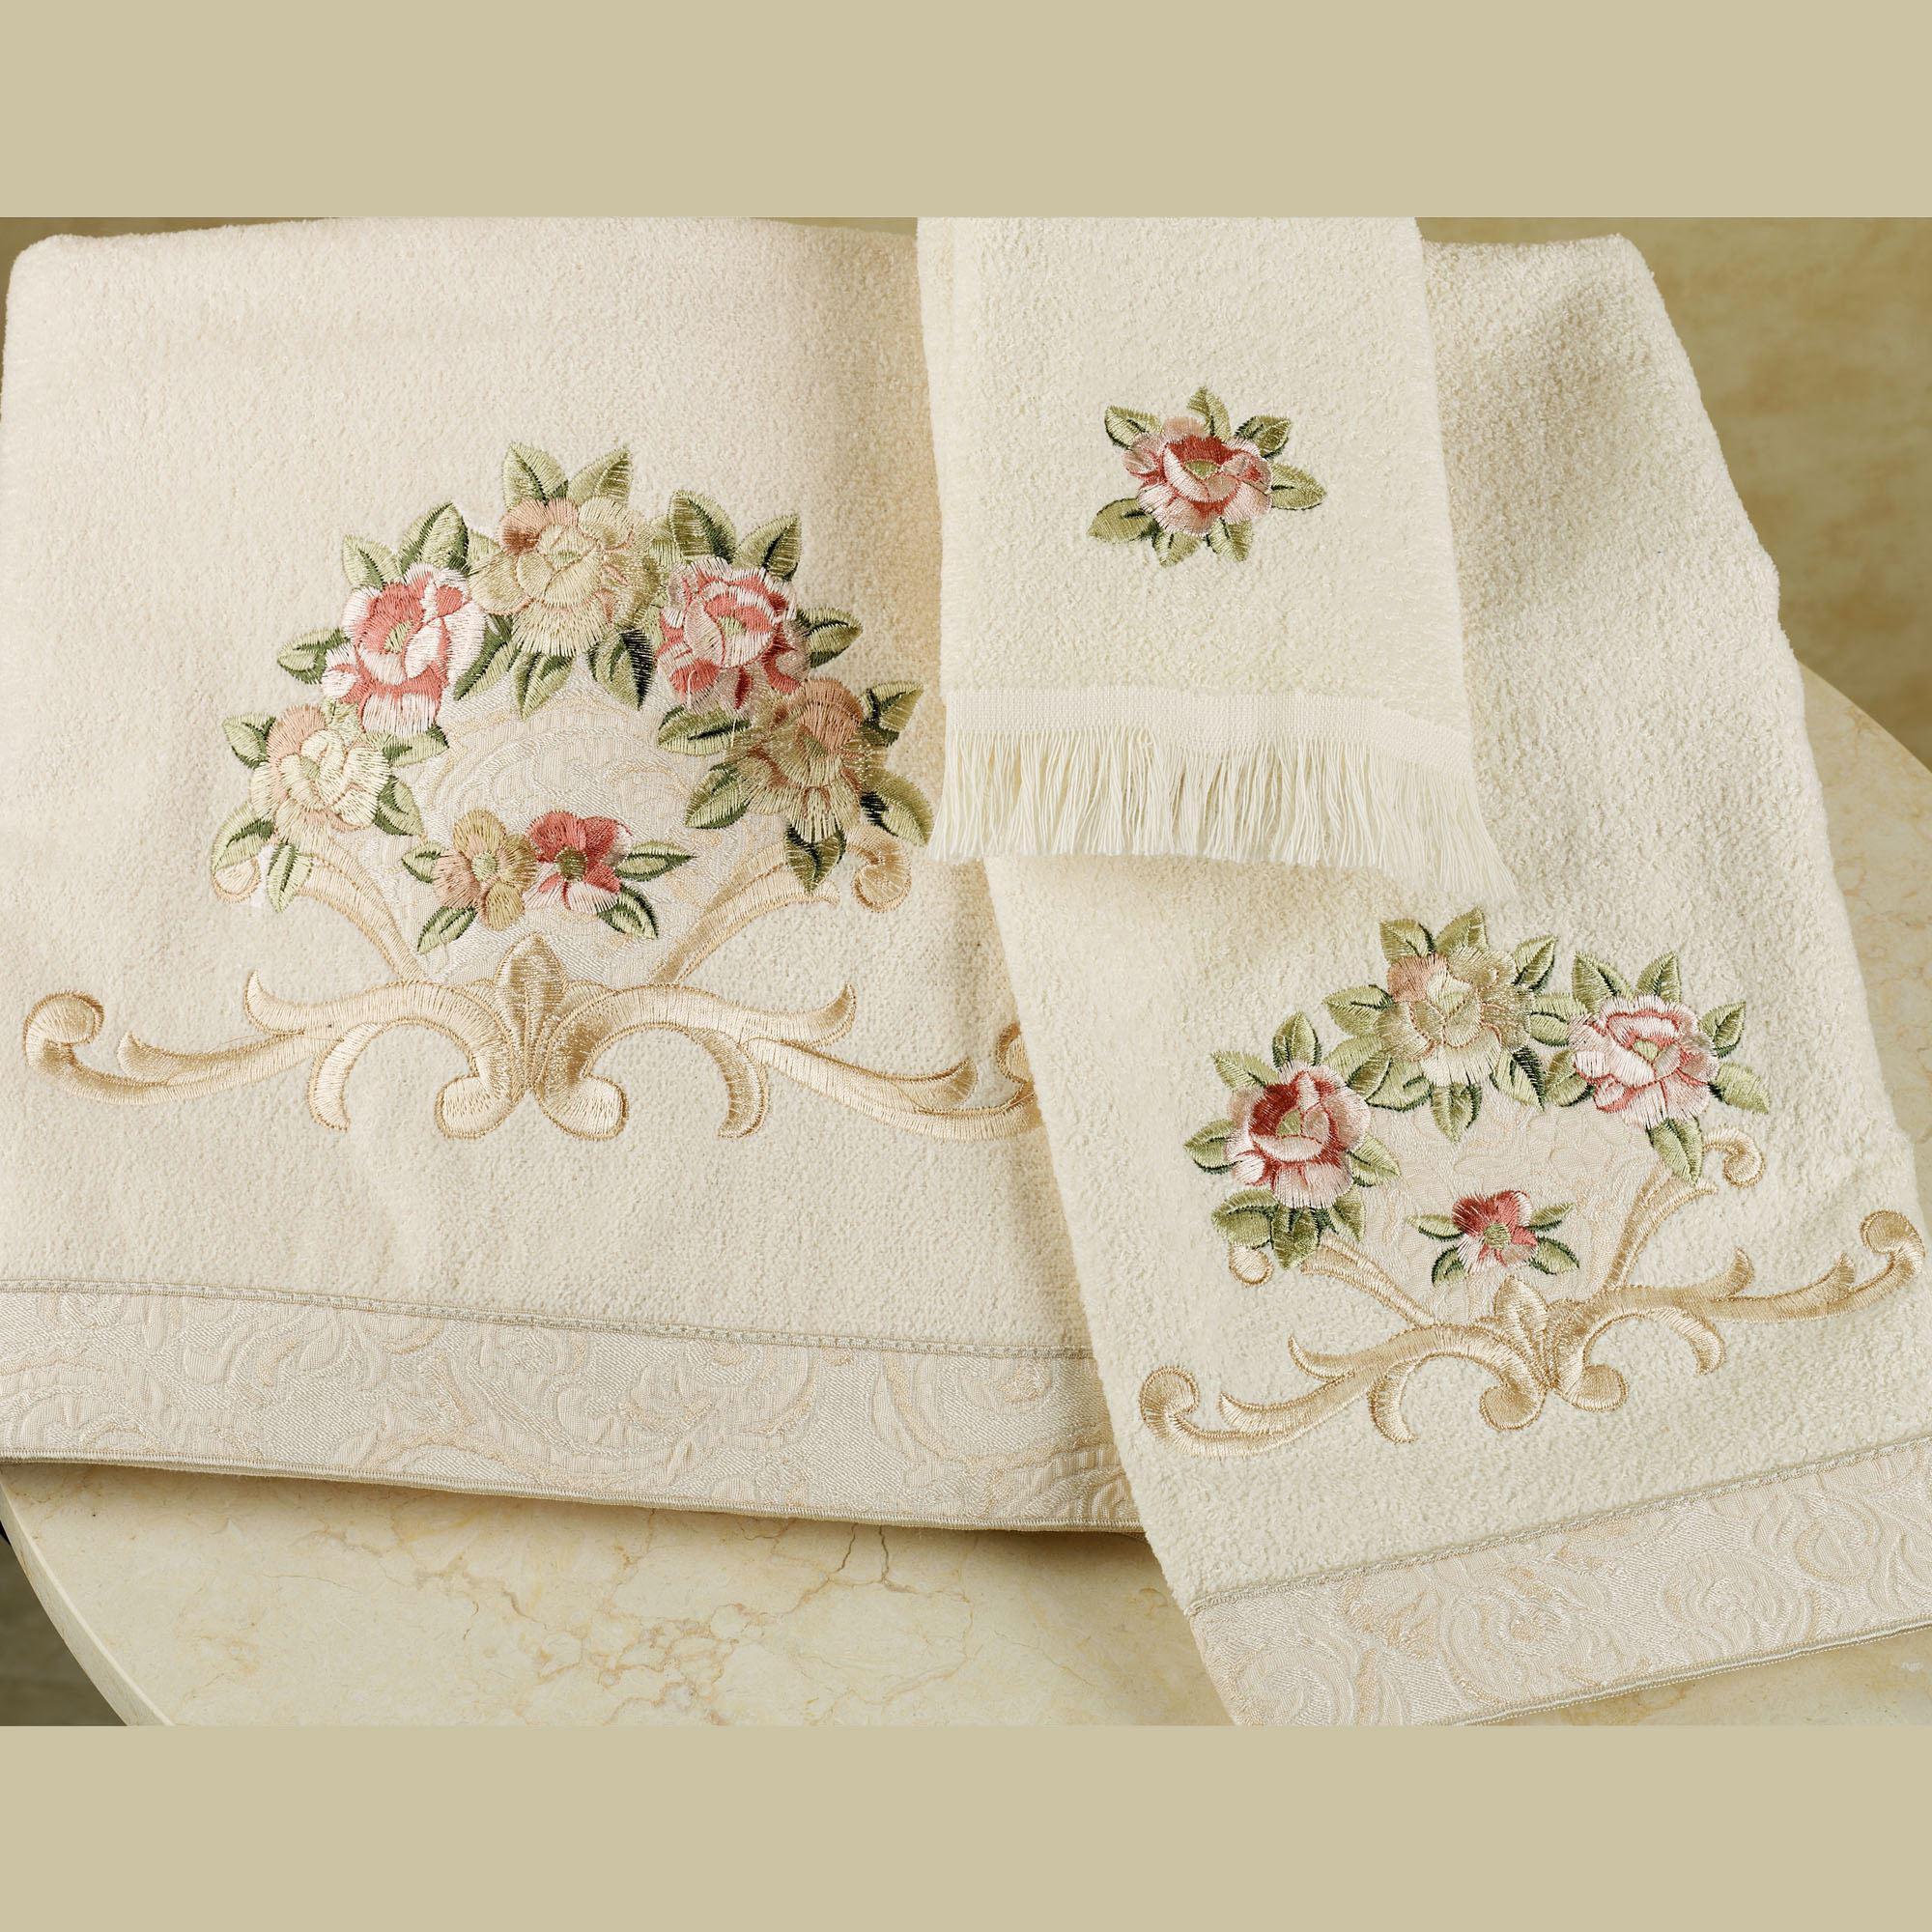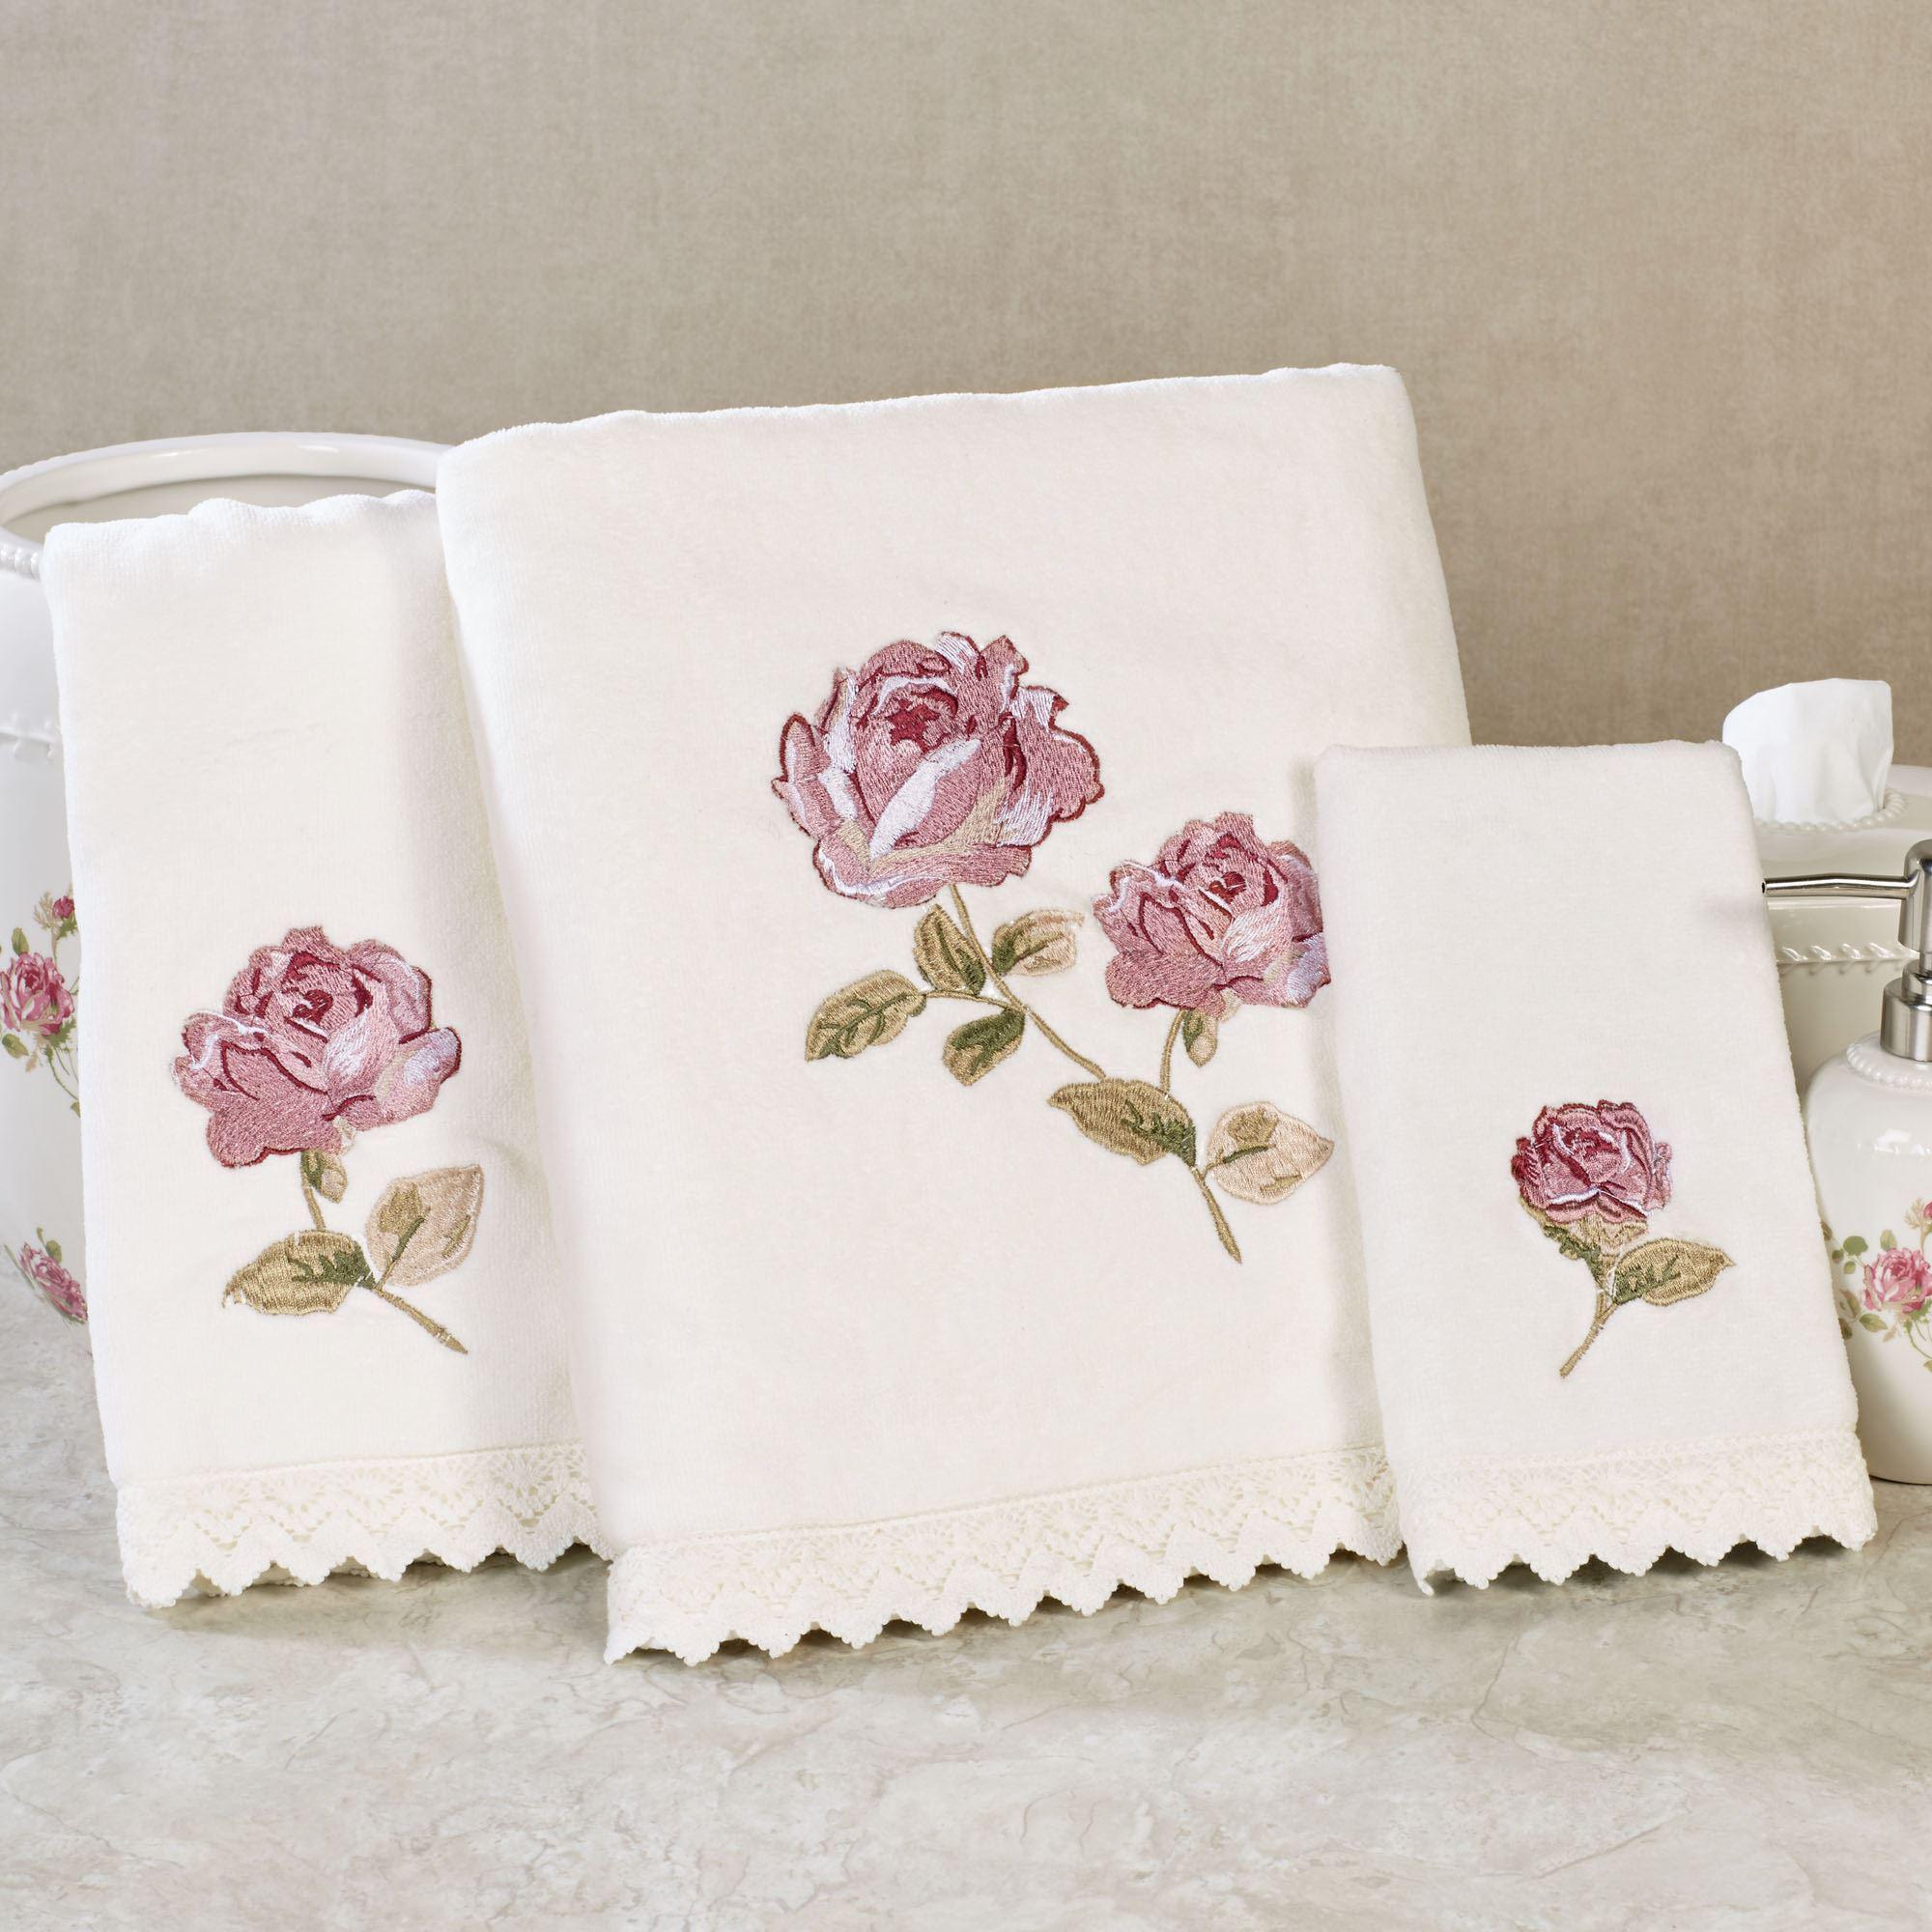The first image is the image on the left, the second image is the image on the right. Examine the images to the left and right. Is the description "There are three towels with birds on them in one of the images." accurate? Answer yes or no. No. The first image is the image on the left, the second image is the image on the right. Analyze the images presented: Is the assertion "Hand towels with birds on them are resting on a counter" valid? Answer yes or no. No. 